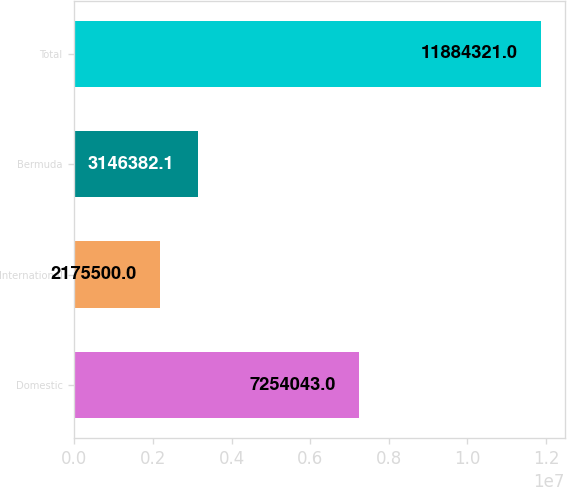Convert chart. <chart><loc_0><loc_0><loc_500><loc_500><bar_chart><fcel>Domestic<fcel>International<fcel>Bermuda<fcel>Total<nl><fcel>7.25404e+06<fcel>2.1755e+06<fcel>3.14638e+06<fcel>1.18843e+07<nl></chart> 